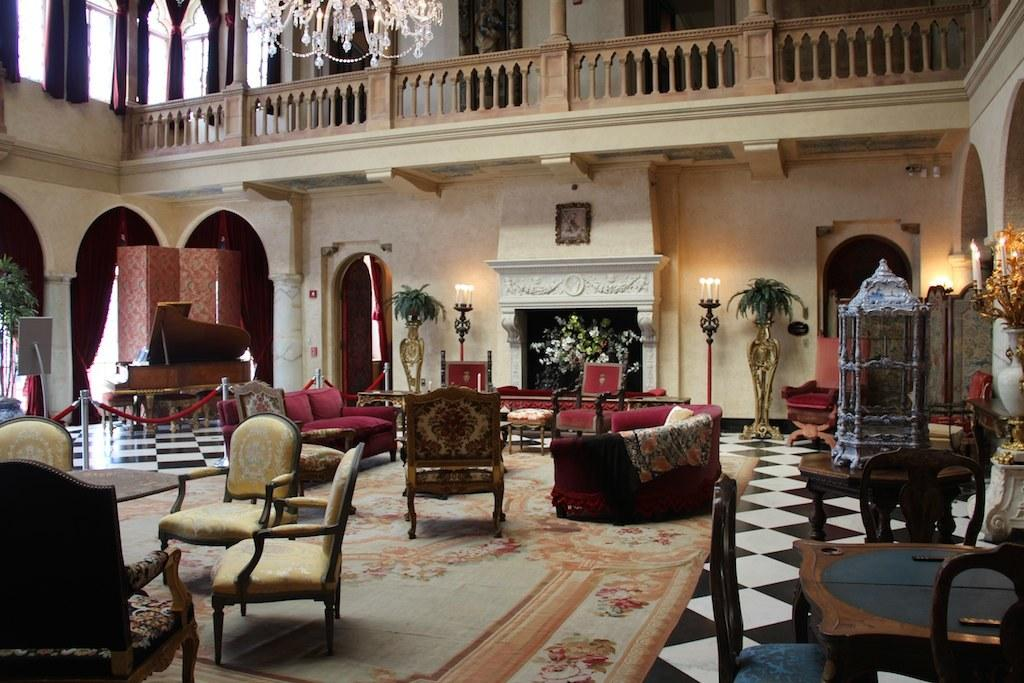What type of furniture is present in the image? There is a table, a chair, and a couch in the image. What type of accessory is present in the image? There is a pillow in the image. What type of decorative item is present in the image? There is a flower pot and a candle stand in the image. What type of structure is visible in the image? There is a building visible in the image. What type of riddle is the father solving on the stage in the image? There is no father, riddle, or stage present in the image. 